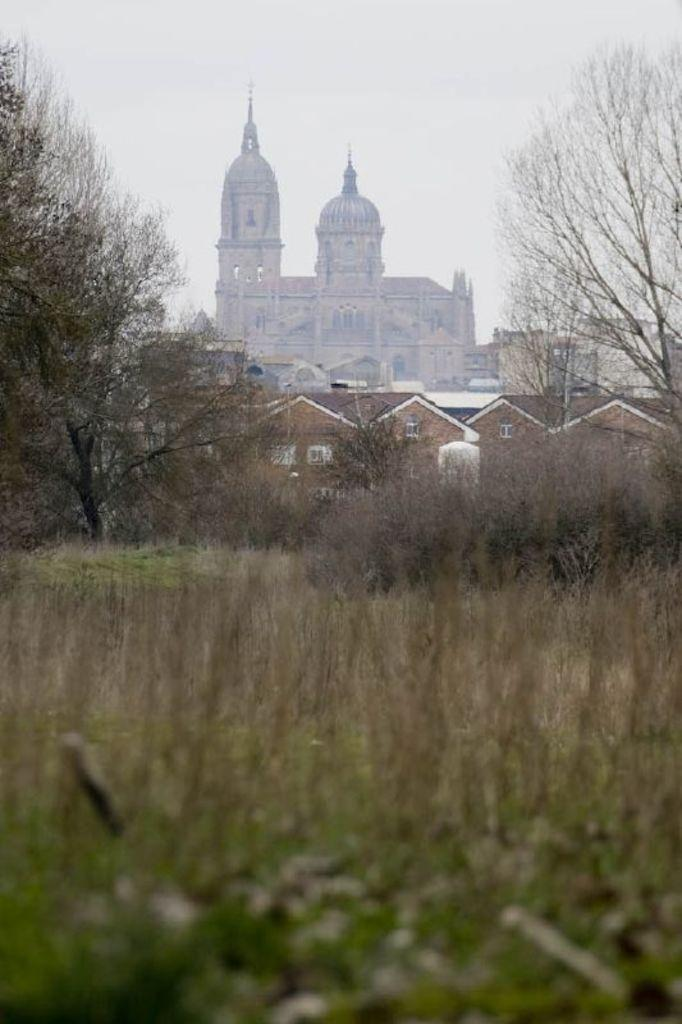What type of vegetation is present in the image? There is grass in the image. What other natural elements can be seen in the image? There are trees in the image. What type of man-made structures are visible in the image? There are buildings in the image. What is visible in the background of the image? The sky is visible in the background of the image. How do the trees in the image perform digestion? Trees do not perform digestion; they are plants that produce their own food through photosynthesis. How many girls are present in the image? There is no mention of girls in the provided facts, so it cannot be determined from the image. 